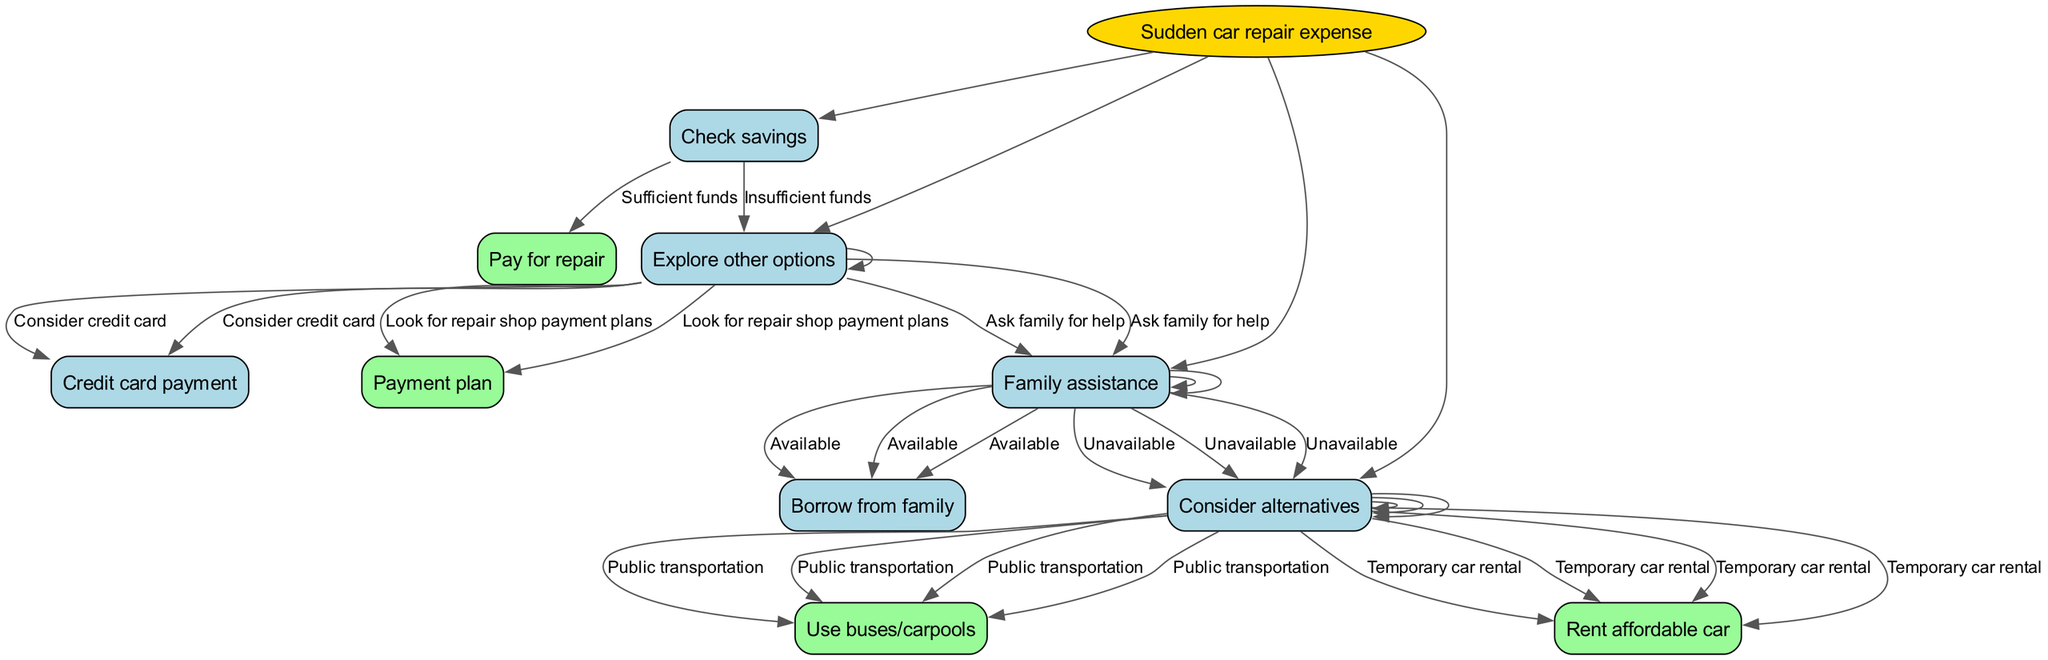What is the root node of the diagram? The root node is "Sudden car repair expense," which is the starting point of the decision tree.
Answer: Sudden car repair expense What are the two options if savings are checked and found to be insufficient? If savings are insufficient, the decision tree directs to "Explore other options," which is the next step in the decision-making process.
Answer: Explore other options How many child nodes does "Explore other options" have? "Explore other options" has three child nodes: "Family assistance," "Credit card payment," and "Payment plan." Counting these gives a total of three.
Answer: 3 What do you need to do if family assistance is unavailable? If family assistance is unavailable, the next step is to "Consider alternatives," which directs the decision tree to further options for handling the repair expense.
Answer: Consider alternatives If you ask family for help and receive assistance, what will you do next? If family assistance is available, the decision would be to "Borrow from family," which is a direct outcome based on the assistance status.
Answer: Borrow from family What action does the diagram suggest if you decide to use public transportation? The diagram specifies that you would "Use buses/carpools," indicating the alternative transportation method after considering public options.
Answer: Use buses/carpools What is the node following "Consider credit card"? After deciding on "Consider credit card," there is no further action branch shown in the specific context of the decision tree layout. Hence, it ends there without additional nodes or edges.
Answer: Credit card payment What is the first action to take if you have sufficient savings? If you have sufficient savings, the first action indicated in the decision tree is to "Pay for repair," which is a straightforward financial decision based on available funds.
Answer: Pay for repair What is the alternative if renting a car is not feasible? If renting a car is not feasible, there are options under "Consider alternatives," such as using public transportation or further exploring feasible alternatives that fit the situation.
Answer: Use buses/carpools or Rent affordable car 